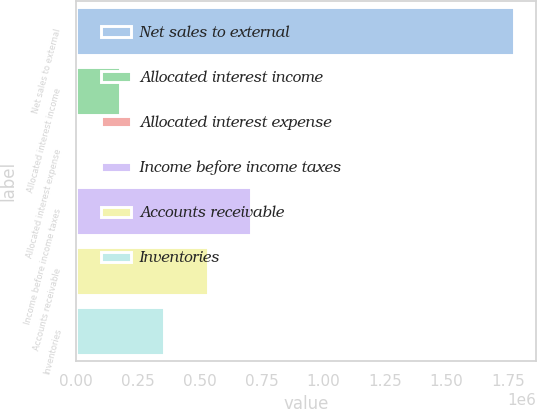Convert chart to OTSL. <chart><loc_0><loc_0><loc_500><loc_500><bar_chart><fcel>Net sales to external<fcel>Allocated interest income<fcel>Allocated interest expense<fcel>Income before income taxes<fcel>Accounts receivable<fcel>Inventories<nl><fcel>1.774e+06<fcel>177437<fcel>41<fcel>709625<fcel>532229<fcel>354833<nl></chart> 